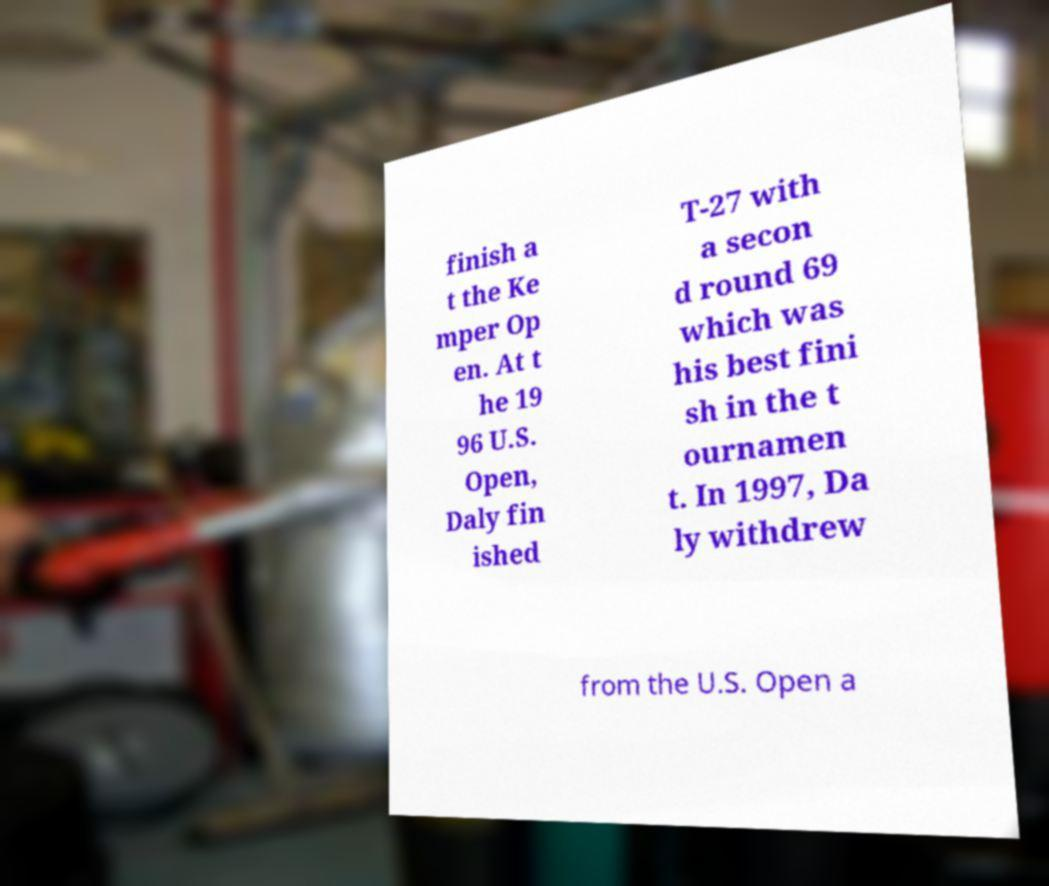What messages or text are displayed in this image? I need them in a readable, typed format. finish a t the Ke mper Op en. At t he 19 96 U.S. Open, Daly fin ished T-27 with a secon d round 69 which was his best fini sh in the t ournamen t. In 1997, Da ly withdrew from the U.S. Open a 